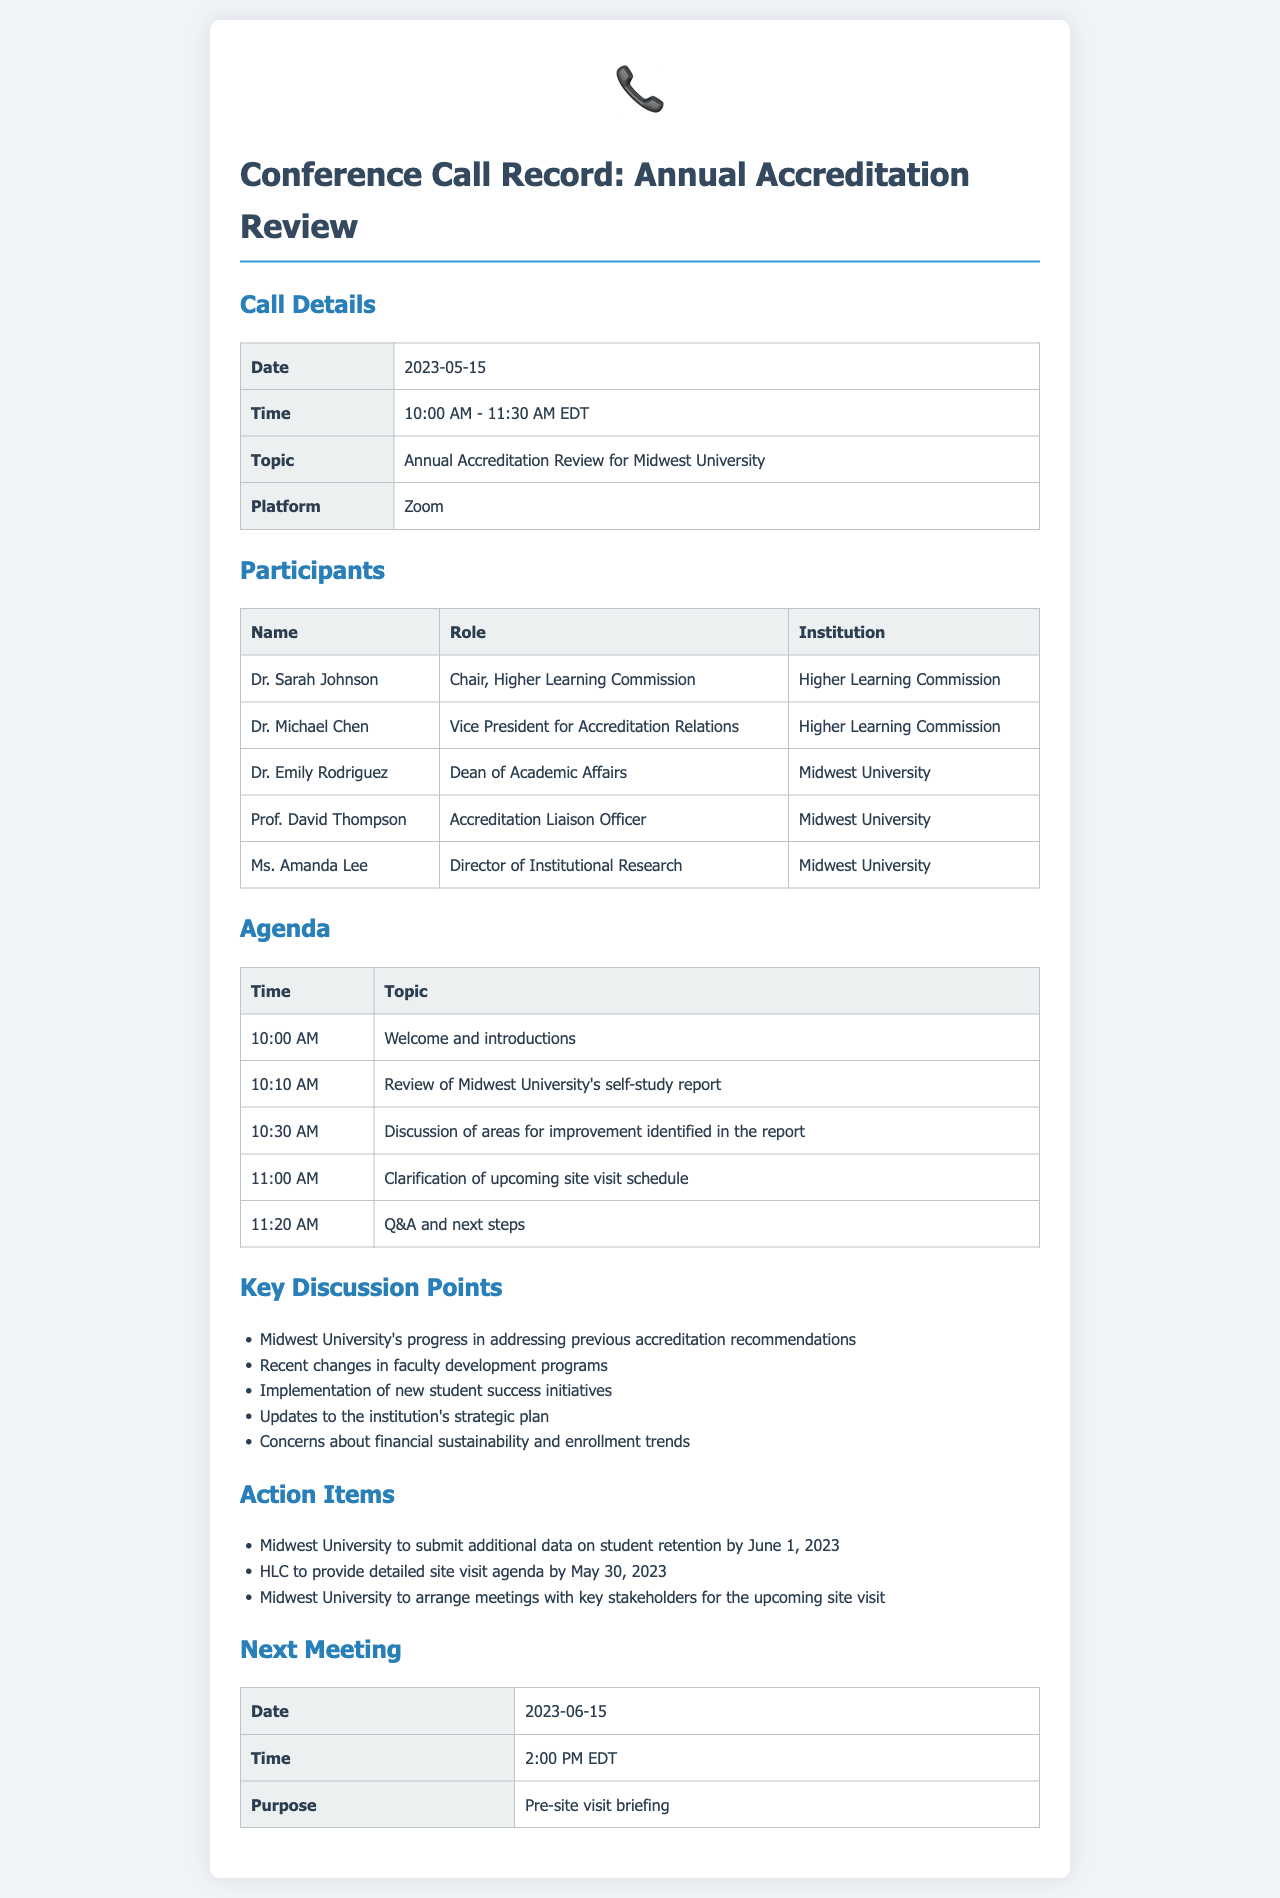What was the date of the conference call? The date of the conference call is explicitly mentioned in the call details section of the document.
Answer: 2023-05-15 Who is the Chair of the Higher Learning Commission? The name of the Chair is stated in the participants section of the document.
Answer: Dr. Sarah Johnson What was the main topic discussed during the call? The main topic is provided in the call details section, specifying what the conference call was about.
Answer: Annual Accreditation Review for Midwest University What time did the call start? The starting time of the call can be found in the call details table.
Answer: 10:00 AM What is the purpose of the next meeting? The purpose of the next meeting is provided in the next meeting section of the document.
Answer: Pre-site visit briefing How many key discussion points were mentioned? The number of discussion points is derived by counting the items listed under key discussion points.
Answer: Five What is one of the action items for Midwest University? One of the action items is specifically listed in the action items section of the document.
Answer: Submit additional data on student retention by June 1, 2023 What is the role of Dr. Michael Chen? The role of Dr. Michael Chen is provided in the participants section of the document.
Answer: Vice President for Accreditation Relations What platform was used for the conference call? The platform used for the conference call is mentioned in the call details section.
Answer: Zoom 